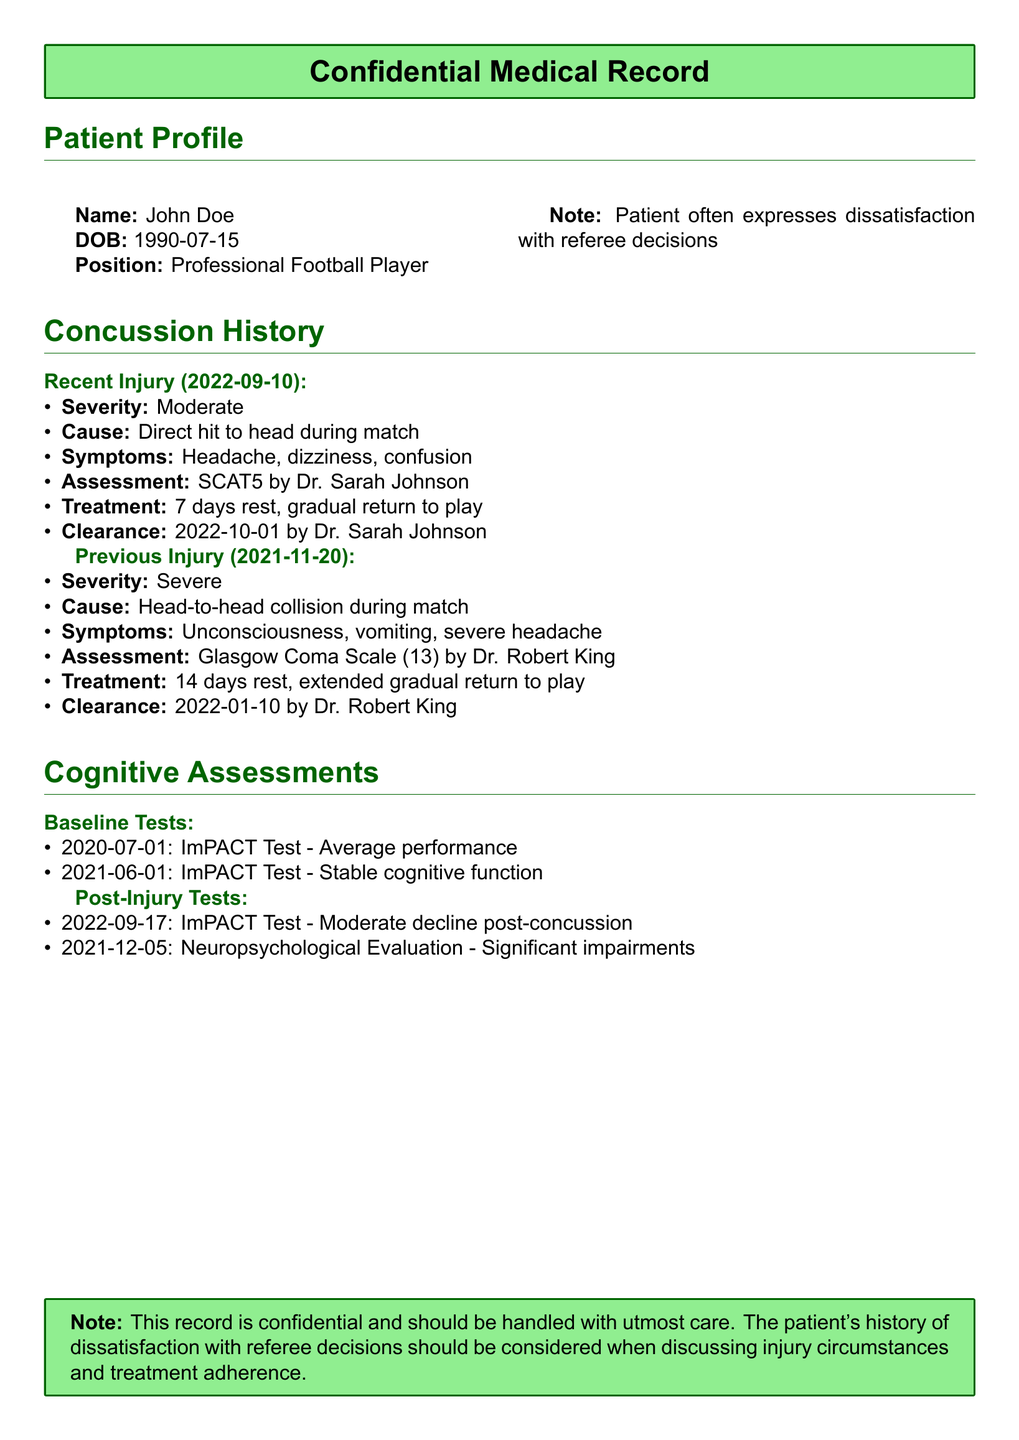what is the name of the patient? The name is provided in the patient profile section of the document.
Answer: John Doe what was the date of the recent injury? The date is listed under the concussion history section for the recent injury.
Answer: 2022-09-10 what was the severity of the previous injury? The severity is mentioned in the previous injury details.
Answer: Severe who performed the assessment for the recent injury? The name is given in the treatment details of the recent injury.
Answer: Dr. Sarah Johnson how many days of rest were prescribed for the recent injury? The number of days is specified in the treatment for that injury.
Answer: 7 days what was the cognitive test result after the recent injury? The results are noted in the post-injury tests section.
Answer: Moderate decline post-concussion what was the clearance date for the previous injury? The clearance date is provided in the details of the previous injury.
Answer: 2022-01-10 how many cognitive assessments were conducted after the previous injury? The document specifies the number of assessments listed under post-injury tests.
Answer: 1 what is the position of the patient? The position is stated in the patient profile section.
Answer: Professional Football Player 